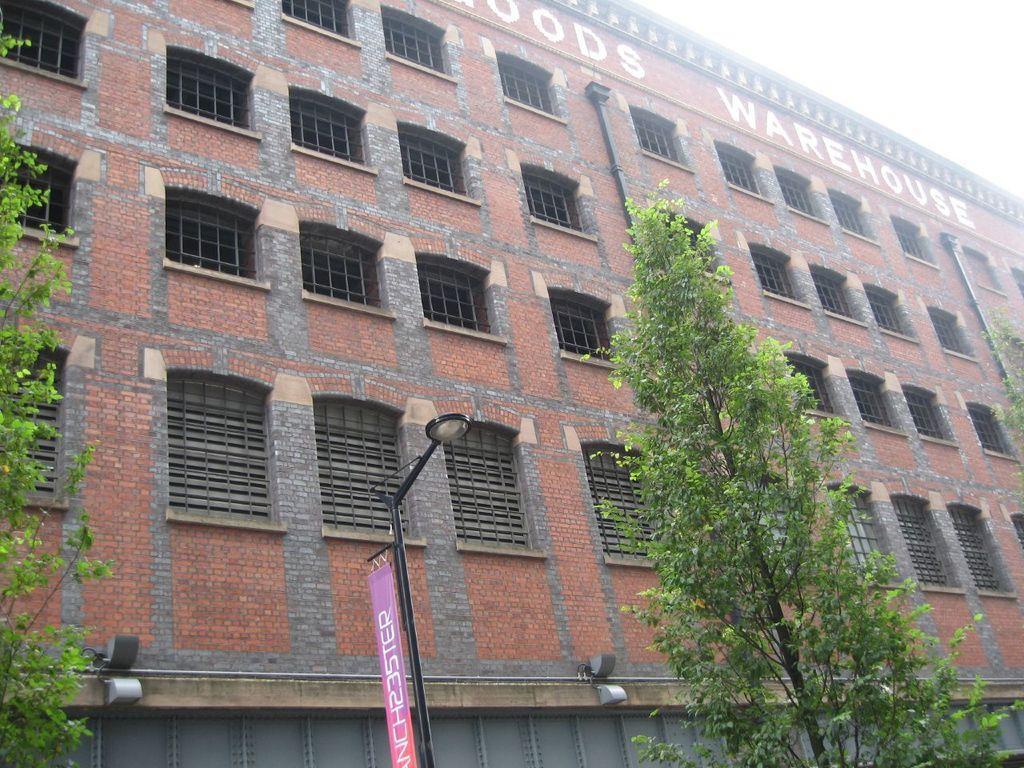Can you describe this image briefly? In this image, we can see building, windows, wall, trees, light pole, banner and pipes. On the building, we can see some text. On the right side top corner, there is the sky. 